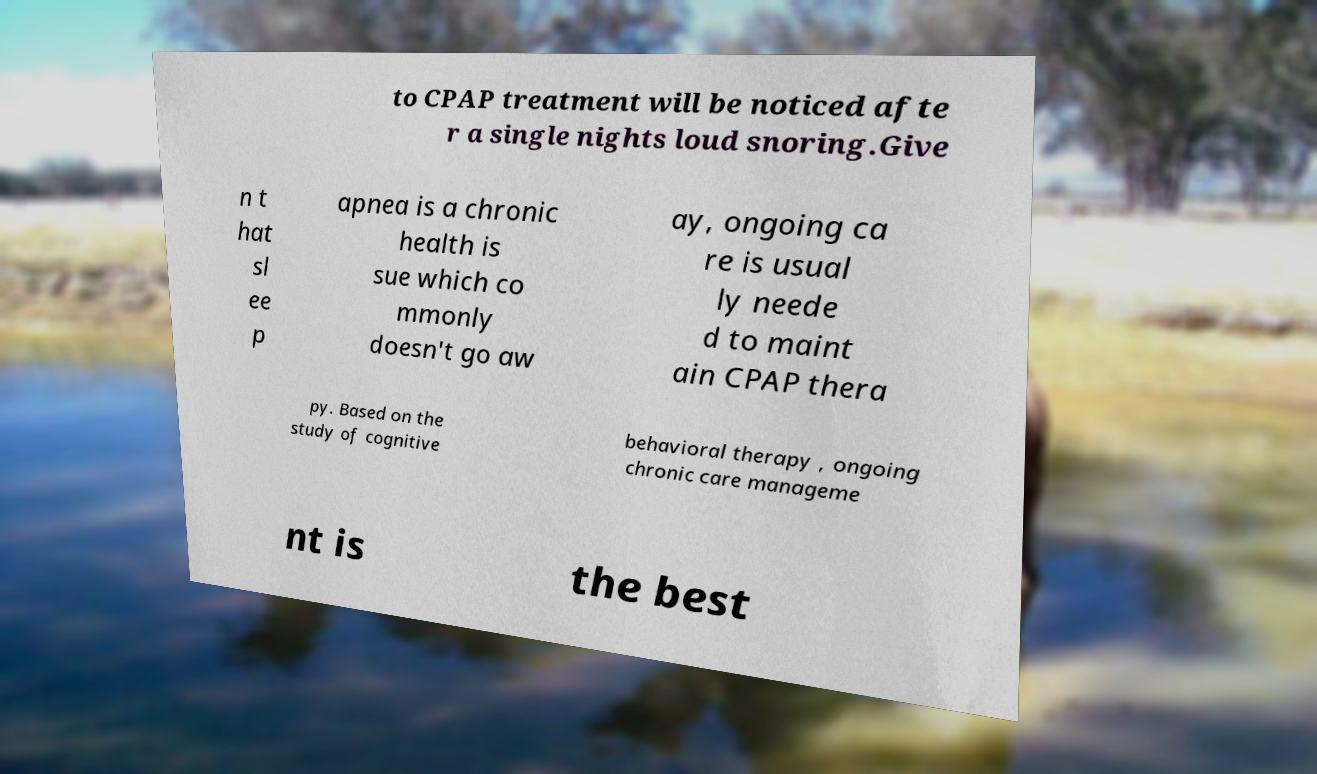Could you assist in decoding the text presented in this image and type it out clearly? to CPAP treatment will be noticed afte r a single nights loud snoring.Give n t hat sl ee p apnea is a chronic health is sue which co mmonly doesn't go aw ay, ongoing ca re is usual ly neede d to maint ain CPAP thera py. Based on the study of cognitive behavioral therapy , ongoing chronic care manageme nt is the best 